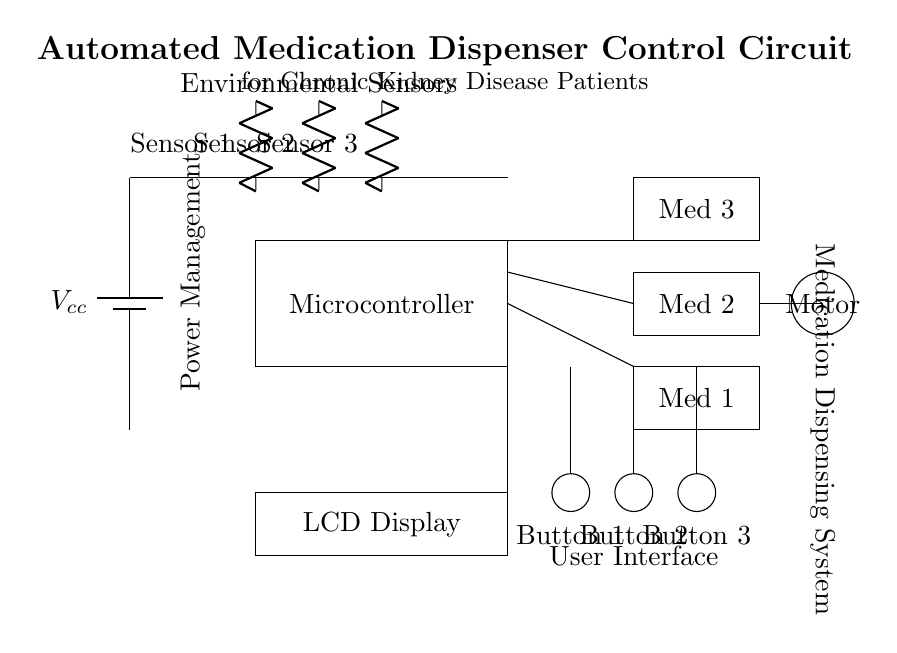What is the power supply used in this circuit? The power supply is labeled as Vcc, indicating it provides the necessary voltage to power the entire circuit.
Answer: Vcc How many medication storage units are present in the circuit? There are three medication storage units labeled as Med 1, Med 2, and Med 3 present in the diagram.
Answer: Three What function do the sensors serve in this circuit? The sensors, labeled as Sensor 1, Sensor 2, and Sensor 3, are likely used to monitor conditions related to the medication dispensing process, such as detecting the presence of medication or confirming dispensing actions.
Answer: Monitoring What is the connection between the microcontroller and the medication storage units? The microcontroller connects to all three medication storage units, indicating it controls and manages the dispensing mechanism based on user inputs and sensor readings.
Answer: Control Which component is responsible for dispensing medication? The dispensing mechanism is represented by a motor in the circuit, which indicates its role in physically dispensing the medication when activated.
Answer: Motor What is the function of the user interface in this circuit? The user interface, consisting of buttons, allows patients or caregivers to interact with the automated system, enabling them to initiate the medication dispensing process or adjust settings.
Answer: Interaction 